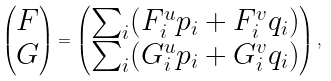<formula> <loc_0><loc_0><loc_500><loc_500>\begin{pmatrix} F \\ G \end{pmatrix} = \begin{pmatrix} \sum _ { i } ( F _ { i } ^ { u } p _ { i } + F _ { i } ^ { v } q _ { i } ) \\ \sum _ { i } ( G _ { i } ^ { u } p _ { i } + G _ { i } ^ { v } q _ { i } ) \end{pmatrix} ,</formula> 